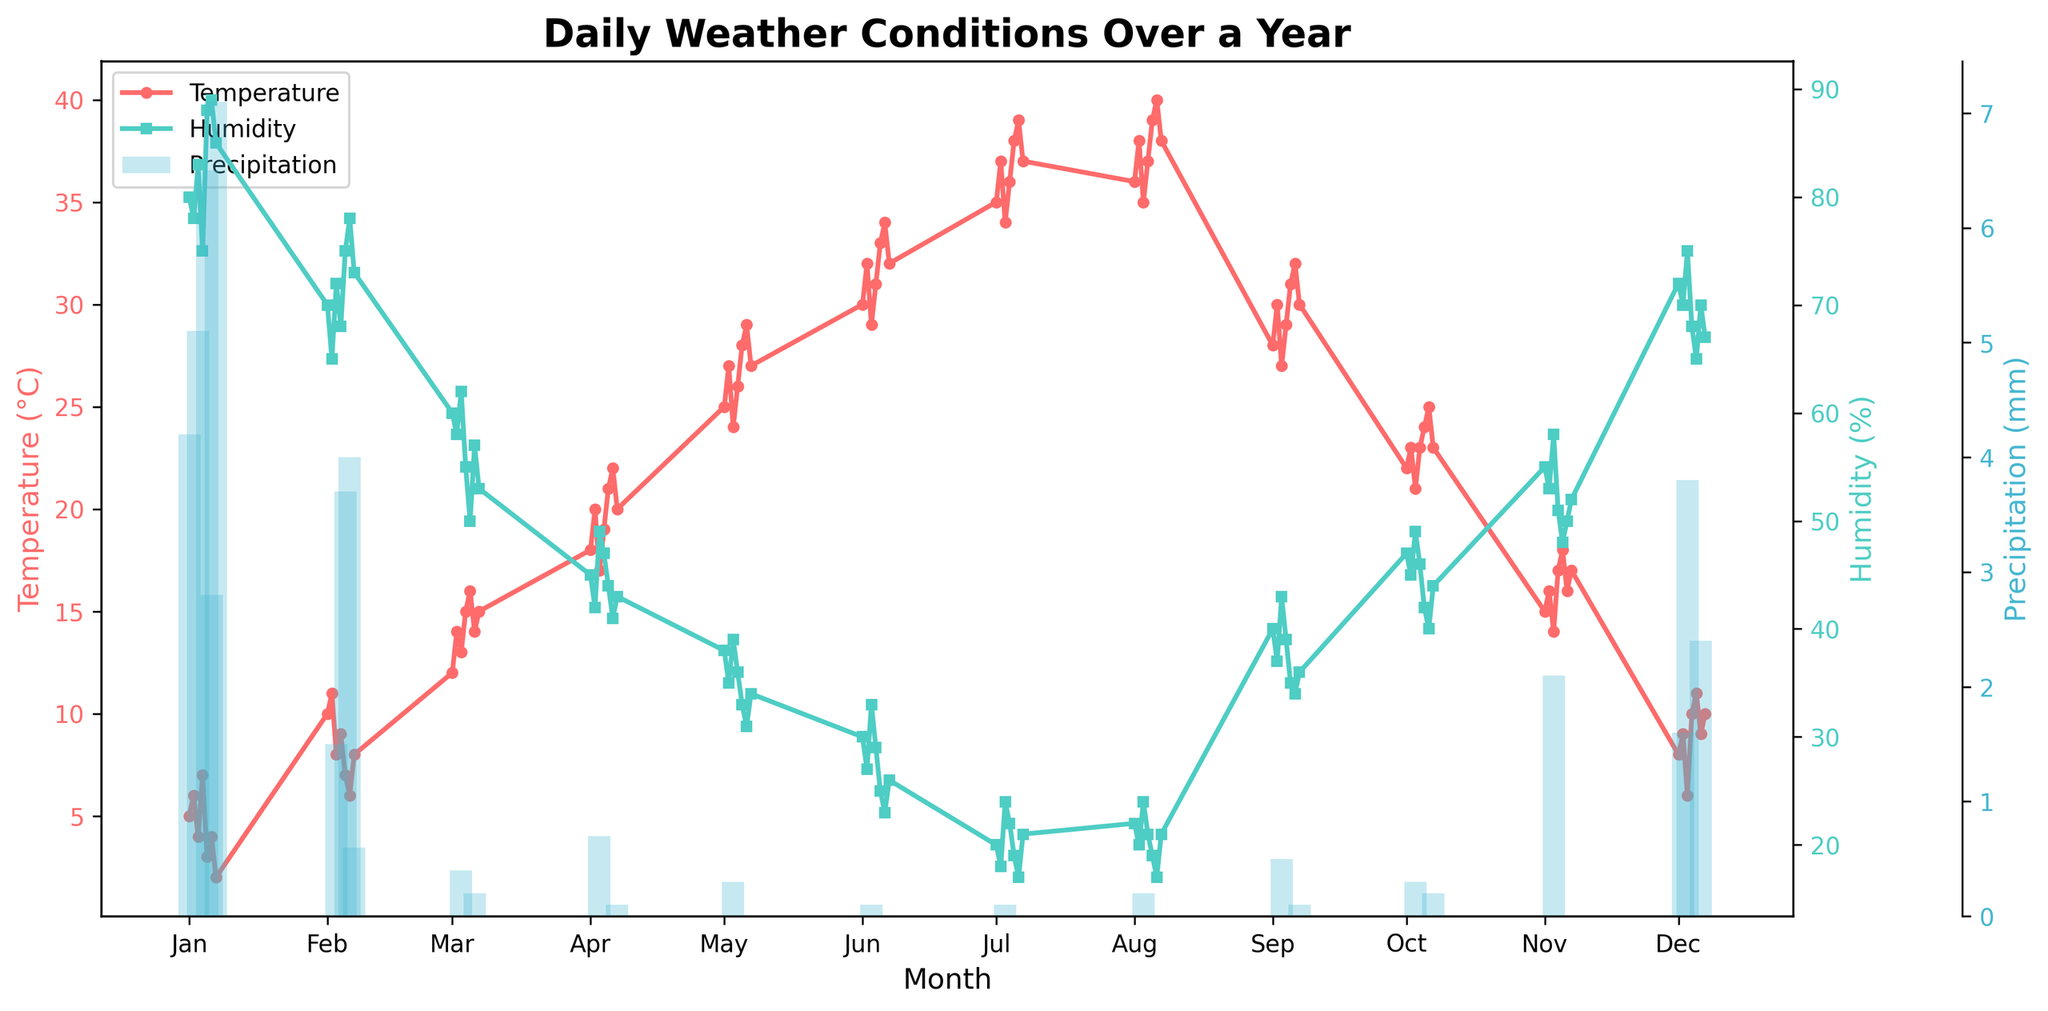How many unique data points are plotted for the temperature in the figure? The figure title indicates "Daily Weather Conditions Over a Year," and since the plot appears to show a daily data point, there should be 365 data points for the temperature curve (one for each day).
Answer: 365 Which month has the highest recorded temperature and what is the value? Looking at the plotted temperature data, July and August show the highest values. The highest temperature is recorded in August, with a value of 40°C.
Answer: August, 40°C Which month has the highest average humidity? To determine the average humidity per month, visually inspect the humidity curve and mentally approximate the area under the curve for each month. July and August have the lowest humidity levels, while the beginning and end of the year have higher values. November seems to have consistently high humidity levels throughout.
Answer: November How many times does precipitation exceed 5 mm in a single day throughout the year? By counting the peaks in the bar chart representing precipitation where the bars exceed the 5 mm mark, we notice it for January 1, January 3, January 5, January 7.
Answer: 4 times Compare the humidity levels between January and July; which month has higher humidity and by what approximate percentage? July has significantly lower humidity levels compared to January. In January, humidity levels are around 80-90%, while in July they are around 17-24%. Taking an average, January has 85% and July has 20%, making January approximately 65% higher in humidity.
Answer: January, by 65% During which months are the precipitation values consistently at their lowest (0 mm)? By looking at the bar chart for precipitation, it is evident that multiple months like July and August exhibit consistently 0 mm precipitation values.
Answer: July and August Which season (Winter, Spring, Summer, or Autumn) has the most distinct increase in temperature over the months? The temperature plot shows a steep increase starting in Spring (March/April) and continuing into early Summer (June). This period sees the most distinct rise in temperature.
Answer: Spring How does the temperature in December compare to the temperature in July? Observing the temperature curve, December shows low temperatures around 6-11°C, while July shows high temperatures around 35-39°C—making December significantly cooler.
Answer: December is cooler than July On what date is the highest precipitation recorded and what is the amount? The highest precipitation is recorded on January 7 with a precipitation value of 7.1 mm, as evident from the height of the bar in the precipitation bar chart.
Answer: January 7, 7.1 mm What trend can you observe about the temperature from January to December? From January to December, the temperature plot shows an increase from January to July, then a decrease from August to December—with July and August having the peak and December returning to cooler temperatures.
Answer: Rise till July, then fall 